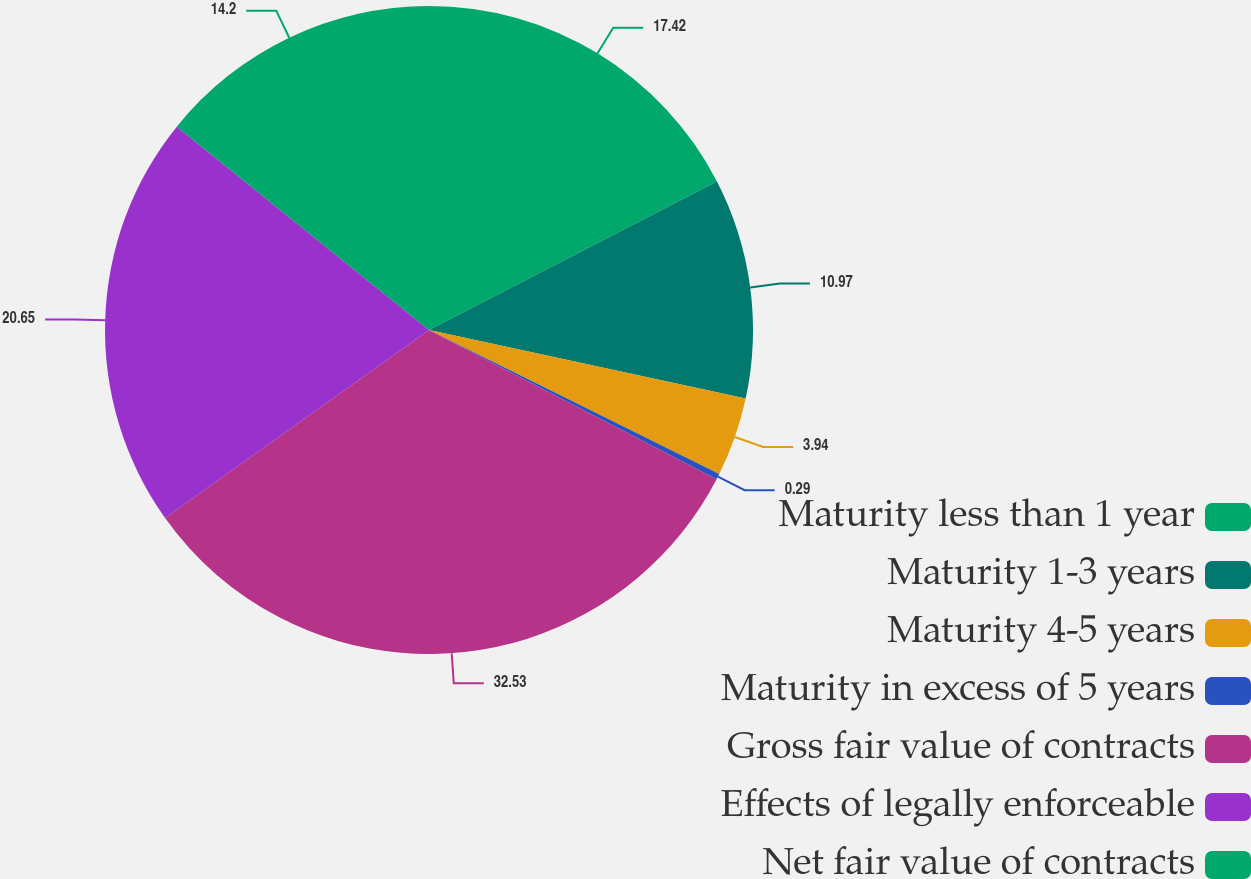<chart> <loc_0><loc_0><loc_500><loc_500><pie_chart><fcel>Maturity less than 1 year<fcel>Maturity 1-3 years<fcel>Maturity 4-5 years<fcel>Maturity in excess of 5 years<fcel>Gross fair value of contracts<fcel>Effects of legally enforceable<fcel>Net fair value of contracts<nl><fcel>17.42%<fcel>10.97%<fcel>3.94%<fcel>0.29%<fcel>32.53%<fcel>20.65%<fcel>14.2%<nl></chart> 